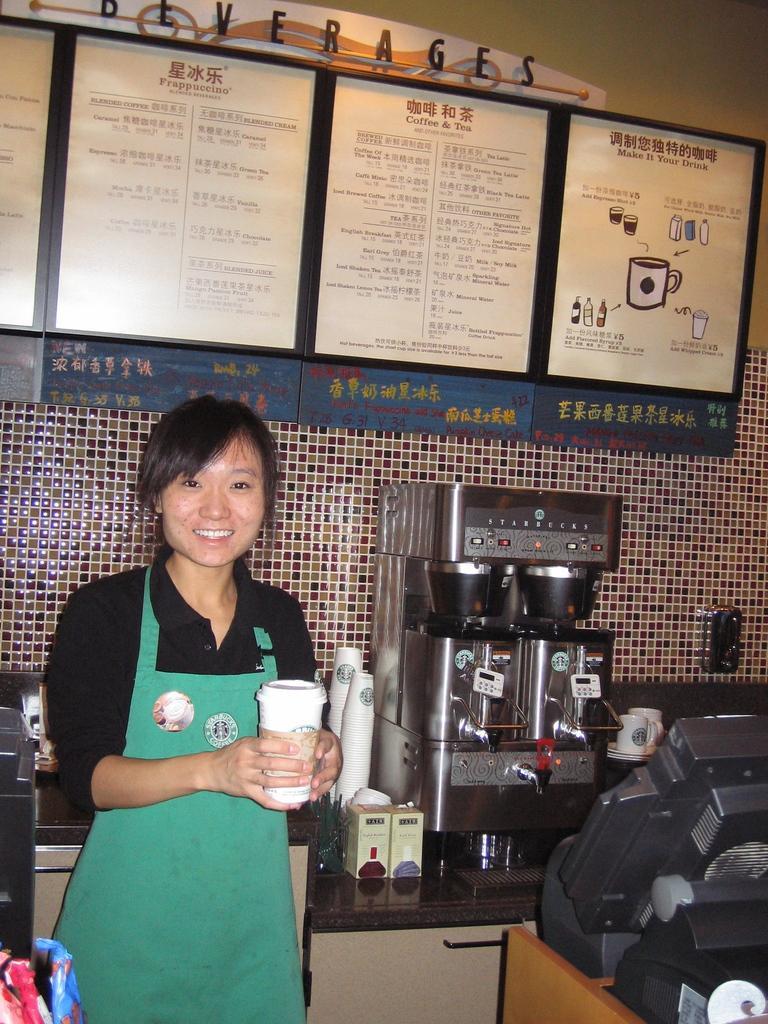Please provide a concise description of this image. The picture is taken in a kitchen. In the foreground of the picture there are some electronic gadgets and a woman holding a cup. In the center of the picture there are cups, coffee machine and other objects. At the top there is a menu card and text. 